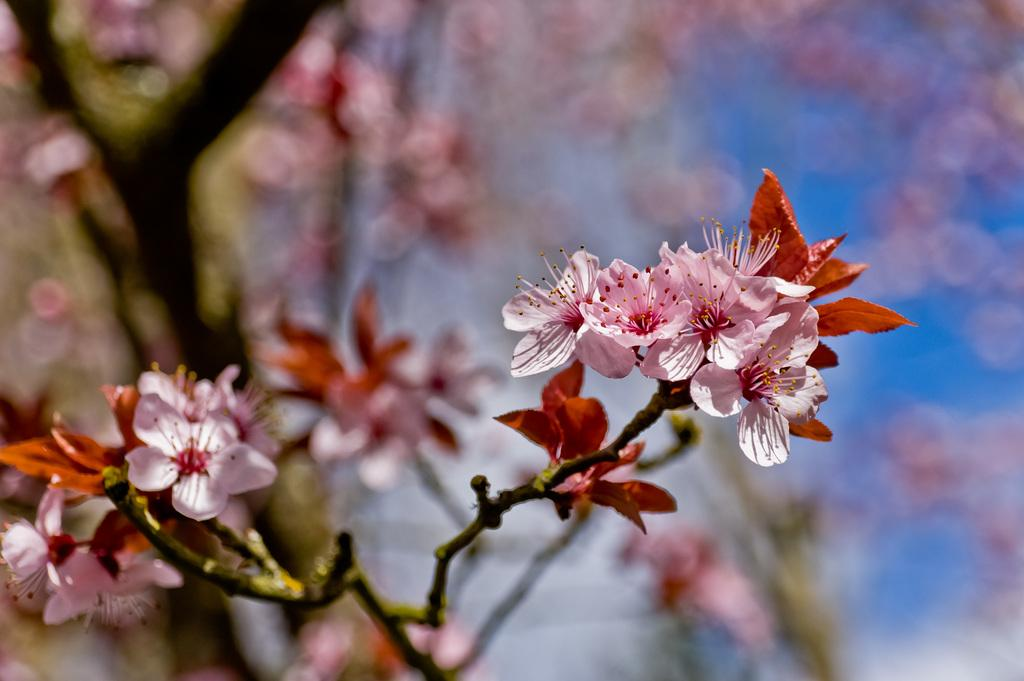What can be seen in the foreground of the picture? There are flowers, leaves, and a stem in the foreground of the picture. What is the condition of the background in the image? The background of the image is blurred. What type of plant can be seen in the background of the picture? There is a tree in the background of the picture. What hobbies does the face in the picture enjoy? There is no face present in the image; it features flowers, leaves, a stem, and a blurred background with a tree. 